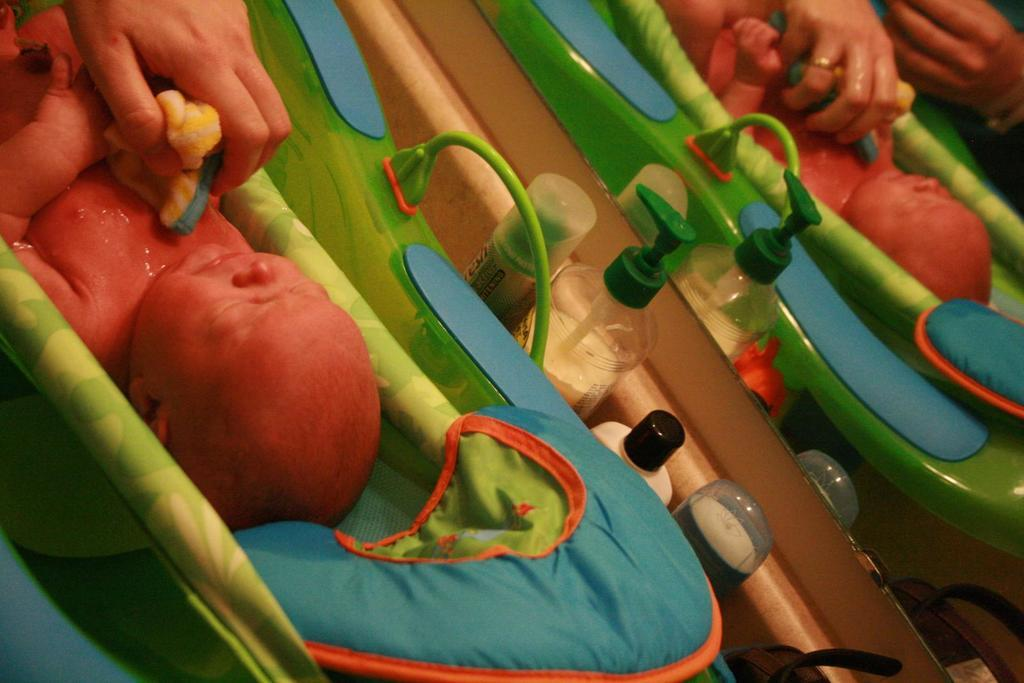What is the main subject of the image? There is a baby in the tub. What else can be seen in the image besides the baby? There are toiletries and a mirror in the image. What is the person in the image doing? A person's hand holding a cloth is visible in the image, and they are cleaning the baby. Can you describe the person's action in more detail? The person is using the cloth to clean the baby. What type of comb is the baby using to say good-bye in the image? There is no comb or good-bye gesture present in the image. The baby is in the tub, and a person is cleaning them with a cloth. 